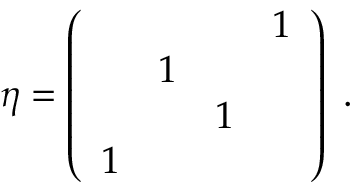<formula> <loc_0><loc_0><loc_500><loc_500>\eta = \left ( \begin{array} { l l l l & { 1 } & { 1 } & { 1 } \\ { 1 } \end{array} \right ) \, .</formula> 